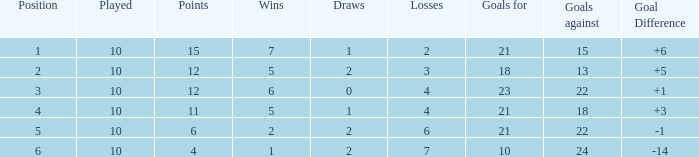What is the least amount of games played for a position above 2, with less than 2 draws and fewer than 18 goals against? None. 